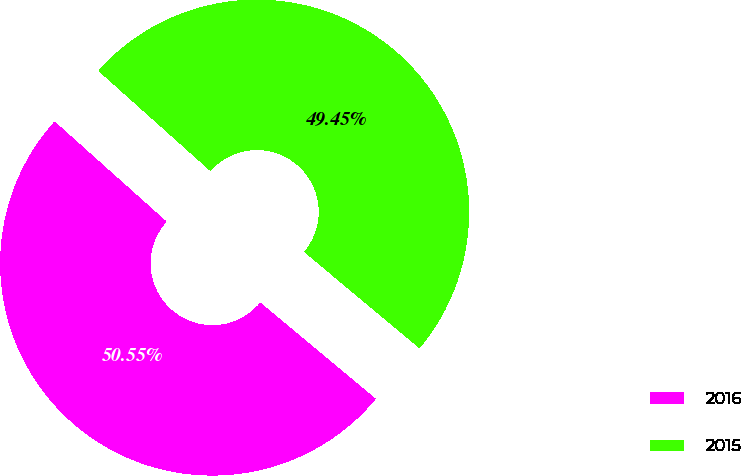<chart> <loc_0><loc_0><loc_500><loc_500><pie_chart><fcel>2016<fcel>2015<nl><fcel>50.55%<fcel>49.45%<nl></chart> 